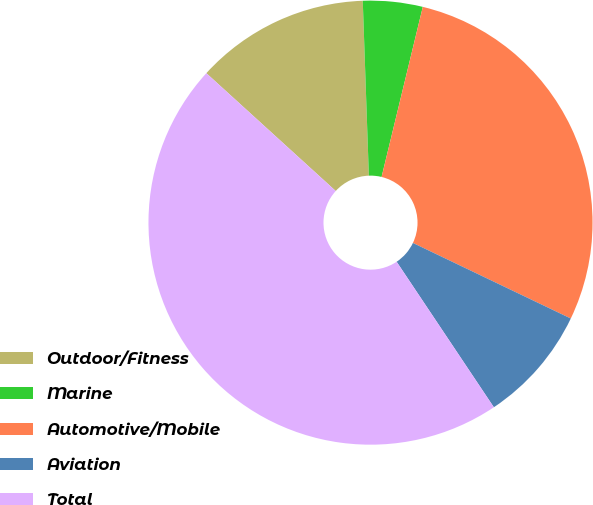Convert chart. <chart><loc_0><loc_0><loc_500><loc_500><pie_chart><fcel>Outdoor/Fitness<fcel>Marine<fcel>Automotive/Mobile<fcel>Aviation<fcel>Total<nl><fcel>12.69%<fcel>4.34%<fcel>28.32%<fcel>8.52%<fcel>46.13%<nl></chart> 